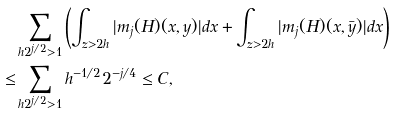Convert formula to latex. <formula><loc_0><loc_0><loc_500><loc_500>& \sum _ { h 2 ^ { j / 2 } > 1 } \left ( \int _ { z > 2 h } | m _ { j } ( H ) ( x , y ) | d x + \int _ { z > 2 h } | m _ { j } ( H ) ( x , \bar { y } ) | d x \right ) \\ \leq & \sum _ { h 2 ^ { j / 2 } > 1 } h ^ { - 1 / 2 } 2 ^ { - j / 4 } \leq C ,</formula> 